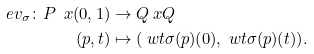Convert formula to latex. <formula><loc_0><loc_0><loc_500><loc_500>e v _ { \sigma } \colon P \ x ( 0 , 1 ) & \to Q \ x Q \\ ( p , t ) & \mapsto ( \ w t { \sigma } ( p ) ( 0 ) , \ w t { \sigma } ( p ) ( t ) ) .</formula> 